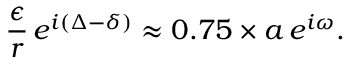Convert formula to latex. <formula><loc_0><loc_0><loc_500><loc_500>\frac { \epsilon } { r } \, e ^ { i ( \Delta - \delta ) } \approx 0 . 7 5 \times a \, e ^ { i \omega } .</formula> 